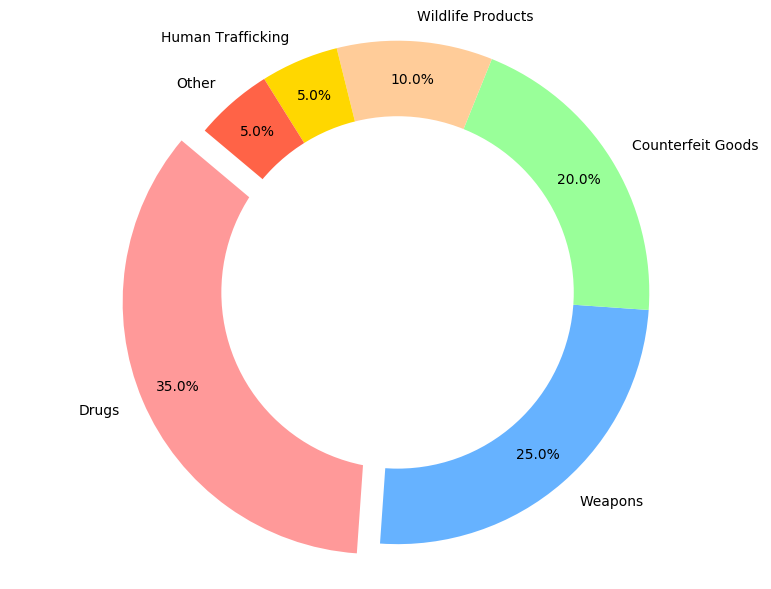What is the most intercepted type of contraband? The pie chart shows that drugs account for the largest percentage of intercepted contraband. This is indicated by the largest section of the pie chart, which is also exploded to highlight it.
Answer: Drugs How many types of contraband make up less than 10% each? The pie chart segments for Wildlife Products, Human Trafficking, and Other are each labeled with percentages of less than 10%. Counting these segments gives us three categories.
Answer: 3 What is the combined percentage of Counterfeit Goods and Wildlife Products? From the pie chart, Counterfeit Goods account for 20% and Wildlife Products account for 10%. Adding these percentages together gives 20% + 10% = 30%.
Answer: 30% Which category has been represented by the smallest segment and what percentage does it account for? The pie chart section labeled "Human Trafficking" is the smallest, accounting for 5% of the intercepted contraband.
Answer: Human Trafficking, 5% How much more prevalent are drugs compared to human trafficking interceptions? According to the pie chart, drugs make up 35% and human trafficking 5%. Subtracting these percentages gives 35% - 5% = 30%.
Answer: 30% What is the difference in the percentage between Weapons and Counterfeit Goods interceptions? The pie chart indicates that Weapons account for 25% and Counterfeit Goods for 20%. Subtracting these gives 25% - 20% = 5%.
Answer: 5% Are Drugs and Weapons interceptions combined more common than all the other categories together? Adding the percentages for Drugs and Weapons gives 35% + 25% = 60%. Summing the remaining categories (20% for Counterfeit Goods, 10% for Wildlife Products, 5% for Human Trafficking, and 5% for Other) also gives 60%. Hence, they are equally common.
Answer: No, it's equal What percentage of interceptions are non-counterfeit illegal items (excluding Counterfeit Goods)? Adding the percentages of non-counterfeit categories (Drugs 35%, Weapons 25%, Wildlife Products 10%, Human Trafficking 5%, and Other 5%) provides 35% + 25% + 10% + 5% + 5% = 80%.
Answer: 80% 